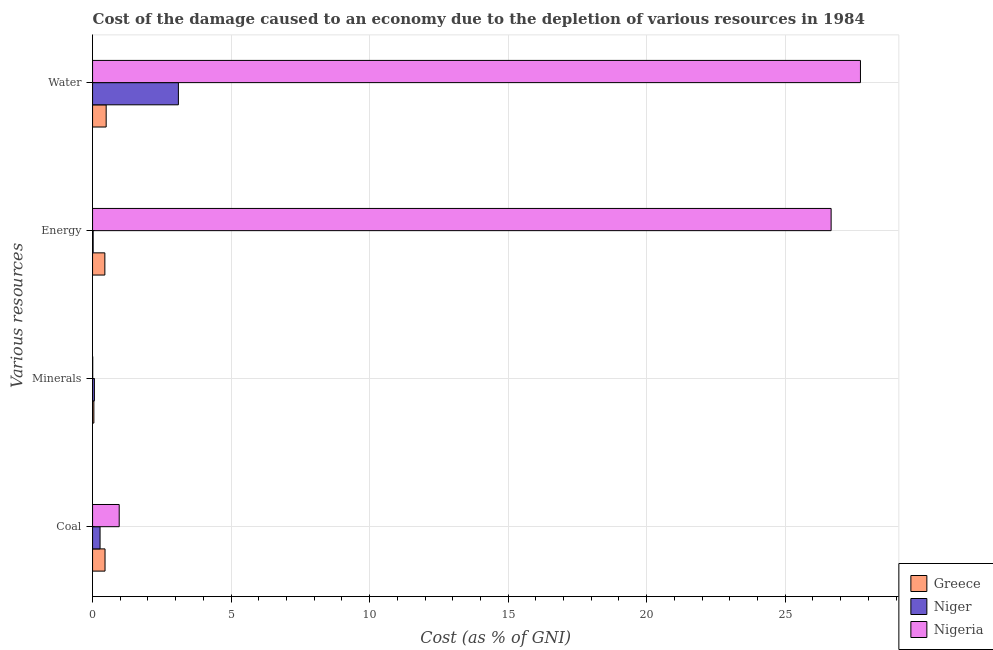How many different coloured bars are there?
Provide a succinct answer. 3. Are the number of bars per tick equal to the number of legend labels?
Your answer should be compact. Yes. Are the number of bars on each tick of the Y-axis equal?
Keep it short and to the point. Yes. How many bars are there on the 4th tick from the top?
Give a very brief answer. 3. How many bars are there on the 1st tick from the bottom?
Make the answer very short. 3. What is the label of the 3rd group of bars from the top?
Provide a short and direct response. Minerals. What is the cost of damage due to depletion of coal in Nigeria?
Keep it short and to the point. 0.96. Across all countries, what is the maximum cost of damage due to depletion of energy?
Ensure brevity in your answer.  26.66. Across all countries, what is the minimum cost of damage due to depletion of water?
Your answer should be very brief. 0.49. In which country was the cost of damage due to depletion of coal maximum?
Your answer should be compact. Nigeria. In which country was the cost of damage due to depletion of energy minimum?
Offer a terse response. Niger. What is the total cost of damage due to depletion of water in the graph?
Offer a very short reply. 31.31. What is the difference between the cost of damage due to depletion of coal in Nigeria and that in Greece?
Your answer should be very brief. 0.51. What is the difference between the cost of damage due to depletion of energy in Niger and the cost of damage due to depletion of coal in Nigeria?
Your answer should be very brief. -0.94. What is the average cost of damage due to depletion of water per country?
Your answer should be compact. 10.44. What is the difference between the cost of damage due to depletion of minerals and cost of damage due to depletion of coal in Greece?
Keep it short and to the point. -0.4. In how many countries, is the cost of damage due to depletion of energy greater than 19 %?
Your answer should be compact. 1. What is the ratio of the cost of damage due to depletion of minerals in Greece to that in Nigeria?
Your answer should be very brief. 8.82. Is the cost of damage due to depletion of minerals in Greece less than that in Niger?
Make the answer very short. Yes. Is the difference between the cost of damage due to depletion of water in Niger and Greece greater than the difference between the cost of damage due to depletion of coal in Niger and Greece?
Give a very brief answer. Yes. What is the difference between the highest and the second highest cost of damage due to depletion of coal?
Give a very brief answer. 0.51. What is the difference between the highest and the lowest cost of damage due to depletion of water?
Ensure brevity in your answer.  27.23. Is the sum of the cost of damage due to depletion of water in Greece and Niger greater than the maximum cost of damage due to depletion of minerals across all countries?
Your answer should be compact. Yes. Is it the case that in every country, the sum of the cost of damage due to depletion of energy and cost of damage due to depletion of minerals is greater than the sum of cost of damage due to depletion of coal and cost of damage due to depletion of water?
Provide a short and direct response. No. What does the 1st bar from the top in Coal represents?
Offer a very short reply. Nigeria. What does the 3rd bar from the bottom in Coal represents?
Your response must be concise. Nigeria. Are all the bars in the graph horizontal?
Provide a succinct answer. Yes. How many countries are there in the graph?
Provide a short and direct response. 3. What is the difference between two consecutive major ticks on the X-axis?
Your answer should be very brief. 5. Does the graph contain grids?
Give a very brief answer. Yes. How many legend labels are there?
Offer a terse response. 3. How are the legend labels stacked?
Make the answer very short. Vertical. What is the title of the graph?
Make the answer very short. Cost of the damage caused to an economy due to the depletion of various resources in 1984 . What is the label or title of the X-axis?
Offer a very short reply. Cost (as % of GNI). What is the label or title of the Y-axis?
Provide a short and direct response. Various resources. What is the Cost (as % of GNI) in Greece in Coal?
Ensure brevity in your answer.  0.45. What is the Cost (as % of GNI) in Niger in Coal?
Ensure brevity in your answer.  0.27. What is the Cost (as % of GNI) in Nigeria in Coal?
Your response must be concise. 0.96. What is the Cost (as % of GNI) in Greece in Minerals?
Ensure brevity in your answer.  0.05. What is the Cost (as % of GNI) of Niger in Minerals?
Your response must be concise. 0.07. What is the Cost (as % of GNI) of Nigeria in Minerals?
Give a very brief answer. 0.01. What is the Cost (as % of GNI) of Greece in Energy?
Give a very brief answer. 0.44. What is the Cost (as % of GNI) of Niger in Energy?
Keep it short and to the point. 0.02. What is the Cost (as % of GNI) of Nigeria in Energy?
Your answer should be very brief. 26.66. What is the Cost (as % of GNI) of Greece in Water?
Your answer should be very brief. 0.49. What is the Cost (as % of GNI) in Niger in Water?
Keep it short and to the point. 3.1. What is the Cost (as % of GNI) in Nigeria in Water?
Offer a very short reply. 27.72. Across all Various resources, what is the maximum Cost (as % of GNI) of Greece?
Make the answer very short. 0.49. Across all Various resources, what is the maximum Cost (as % of GNI) in Niger?
Keep it short and to the point. 3.1. Across all Various resources, what is the maximum Cost (as % of GNI) in Nigeria?
Keep it short and to the point. 27.72. Across all Various resources, what is the minimum Cost (as % of GNI) in Greece?
Offer a terse response. 0.05. Across all Various resources, what is the minimum Cost (as % of GNI) in Niger?
Provide a succinct answer. 0.02. Across all Various resources, what is the minimum Cost (as % of GNI) in Nigeria?
Offer a very short reply. 0.01. What is the total Cost (as % of GNI) of Greece in the graph?
Your answer should be compact. 1.43. What is the total Cost (as % of GNI) of Niger in the graph?
Give a very brief answer. 3.46. What is the total Cost (as % of GNI) of Nigeria in the graph?
Make the answer very short. 55.34. What is the difference between the Cost (as % of GNI) of Greece in Coal and that in Minerals?
Offer a very short reply. 0.4. What is the difference between the Cost (as % of GNI) of Niger in Coal and that in Minerals?
Give a very brief answer. 0.2. What is the difference between the Cost (as % of GNI) of Nigeria in Coal and that in Minerals?
Your answer should be very brief. 0.96. What is the difference between the Cost (as % of GNI) in Greece in Coal and that in Energy?
Ensure brevity in your answer.  0.01. What is the difference between the Cost (as % of GNI) in Niger in Coal and that in Energy?
Offer a terse response. 0.25. What is the difference between the Cost (as % of GNI) of Nigeria in Coal and that in Energy?
Ensure brevity in your answer.  -25.7. What is the difference between the Cost (as % of GNI) of Greece in Coal and that in Water?
Your answer should be compact. -0.04. What is the difference between the Cost (as % of GNI) of Niger in Coal and that in Water?
Make the answer very short. -2.83. What is the difference between the Cost (as % of GNI) of Nigeria in Coal and that in Water?
Provide a succinct answer. -26.76. What is the difference between the Cost (as % of GNI) in Greece in Minerals and that in Energy?
Give a very brief answer. -0.4. What is the difference between the Cost (as % of GNI) of Niger in Minerals and that in Energy?
Your answer should be very brief. 0.04. What is the difference between the Cost (as % of GNI) of Nigeria in Minerals and that in Energy?
Make the answer very short. -26.65. What is the difference between the Cost (as % of GNI) in Greece in Minerals and that in Water?
Make the answer very short. -0.44. What is the difference between the Cost (as % of GNI) of Niger in Minerals and that in Water?
Give a very brief answer. -3.03. What is the difference between the Cost (as % of GNI) of Nigeria in Minerals and that in Water?
Offer a very short reply. -27.71. What is the difference between the Cost (as % of GNI) of Greece in Energy and that in Water?
Keep it short and to the point. -0.05. What is the difference between the Cost (as % of GNI) in Niger in Energy and that in Water?
Your response must be concise. -3.08. What is the difference between the Cost (as % of GNI) in Nigeria in Energy and that in Water?
Keep it short and to the point. -1.06. What is the difference between the Cost (as % of GNI) in Greece in Coal and the Cost (as % of GNI) in Niger in Minerals?
Keep it short and to the point. 0.38. What is the difference between the Cost (as % of GNI) of Greece in Coal and the Cost (as % of GNI) of Nigeria in Minerals?
Give a very brief answer. 0.44. What is the difference between the Cost (as % of GNI) in Niger in Coal and the Cost (as % of GNI) in Nigeria in Minerals?
Provide a short and direct response. 0.27. What is the difference between the Cost (as % of GNI) of Greece in Coal and the Cost (as % of GNI) of Niger in Energy?
Offer a terse response. 0.43. What is the difference between the Cost (as % of GNI) in Greece in Coal and the Cost (as % of GNI) in Nigeria in Energy?
Ensure brevity in your answer.  -26.21. What is the difference between the Cost (as % of GNI) of Niger in Coal and the Cost (as % of GNI) of Nigeria in Energy?
Your response must be concise. -26.39. What is the difference between the Cost (as % of GNI) in Greece in Coal and the Cost (as % of GNI) in Niger in Water?
Your response must be concise. -2.65. What is the difference between the Cost (as % of GNI) in Greece in Coal and the Cost (as % of GNI) in Nigeria in Water?
Provide a short and direct response. -27.27. What is the difference between the Cost (as % of GNI) of Niger in Coal and the Cost (as % of GNI) of Nigeria in Water?
Provide a succinct answer. -27.45. What is the difference between the Cost (as % of GNI) in Greece in Minerals and the Cost (as % of GNI) in Niger in Energy?
Give a very brief answer. 0.03. What is the difference between the Cost (as % of GNI) of Greece in Minerals and the Cost (as % of GNI) of Nigeria in Energy?
Your answer should be compact. -26.61. What is the difference between the Cost (as % of GNI) in Niger in Minerals and the Cost (as % of GNI) in Nigeria in Energy?
Provide a short and direct response. -26.59. What is the difference between the Cost (as % of GNI) in Greece in Minerals and the Cost (as % of GNI) in Niger in Water?
Your answer should be very brief. -3.05. What is the difference between the Cost (as % of GNI) of Greece in Minerals and the Cost (as % of GNI) of Nigeria in Water?
Your answer should be very brief. -27.67. What is the difference between the Cost (as % of GNI) in Niger in Minerals and the Cost (as % of GNI) in Nigeria in Water?
Provide a succinct answer. -27.65. What is the difference between the Cost (as % of GNI) of Greece in Energy and the Cost (as % of GNI) of Niger in Water?
Your answer should be compact. -2.65. What is the difference between the Cost (as % of GNI) in Greece in Energy and the Cost (as % of GNI) in Nigeria in Water?
Give a very brief answer. -27.27. What is the difference between the Cost (as % of GNI) in Niger in Energy and the Cost (as % of GNI) in Nigeria in Water?
Your answer should be compact. -27.7. What is the average Cost (as % of GNI) of Greece per Various resources?
Your answer should be compact. 0.36. What is the average Cost (as % of GNI) in Niger per Various resources?
Offer a terse response. 0.86. What is the average Cost (as % of GNI) in Nigeria per Various resources?
Offer a terse response. 13.84. What is the difference between the Cost (as % of GNI) in Greece and Cost (as % of GNI) in Niger in Coal?
Ensure brevity in your answer.  0.18. What is the difference between the Cost (as % of GNI) of Greece and Cost (as % of GNI) of Nigeria in Coal?
Your answer should be very brief. -0.51. What is the difference between the Cost (as % of GNI) in Niger and Cost (as % of GNI) in Nigeria in Coal?
Ensure brevity in your answer.  -0.69. What is the difference between the Cost (as % of GNI) in Greece and Cost (as % of GNI) in Niger in Minerals?
Ensure brevity in your answer.  -0.02. What is the difference between the Cost (as % of GNI) of Greece and Cost (as % of GNI) of Nigeria in Minerals?
Offer a terse response. 0.04. What is the difference between the Cost (as % of GNI) of Niger and Cost (as % of GNI) of Nigeria in Minerals?
Your answer should be compact. 0.06. What is the difference between the Cost (as % of GNI) in Greece and Cost (as % of GNI) in Niger in Energy?
Give a very brief answer. 0.42. What is the difference between the Cost (as % of GNI) of Greece and Cost (as % of GNI) of Nigeria in Energy?
Your answer should be very brief. -26.21. What is the difference between the Cost (as % of GNI) in Niger and Cost (as % of GNI) in Nigeria in Energy?
Your response must be concise. -26.64. What is the difference between the Cost (as % of GNI) of Greece and Cost (as % of GNI) of Niger in Water?
Ensure brevity in your answer.  -2.61. What is the difference between the Cost (as % of GNI) of Greece and Cost (as % of GNI) of Nigeria in Water?
Keep it short and to the point. -27.23. What is the difference between the Cost (as % of GNI) in Niger and Cost (as % of GNI) in Nigeria in Water?
Your response must be concise. -24.62. What is the ratio of the Cost (as % of GNI) of Greece in Coal to that in Minerals?
Provide a succinct answer. 9.53. What is the ratio of the Cost (as % of GNI) in Niger in Coal to that in Minerals?
Your response must be concise. 4.1. What is the ratio of the Cost (as % of GNI) of Nigeria in Coal to that in Minerals?
Provide a short and direct response. 179.5. What is the ratio of the Cost (as % of GNI) in Niger in Coal to that in Energy?
Ensure brevity in your answer.  12.71. What is the ratio of the Cost (as % of GNI) in Nigeria in Coal to that in Energy?
Offer a terse response. 0.04. What is the ratio of the Cost (as % of GNI) in Greece in Coal to that in Water?
Make the answer very short. 0.92. What is the ratio of the Cost (as % of GNI) in Niger in Coal to that in Water?
Your answer should be compact. 0.09. What is the ratio of the Cost (as % of GNI) of Nigeria in Coal to that in Water?
Your answer should be compact. 0.03. What is the ratio of the Cost (as % of GNI) of Greece in Minerals to that in Energy?
Give a very brief answer. 0.11. What is the ratio of the Cost (as % of GNI) in Niger in Minerals to that in Energy?
Your answer should be compact. 3.1. What is the ratio of the Cost (as % of GNI) of Nigeria in Minerals to that in Energy?
Keep it short and to the point. 0. What is the ratio of the Cost (as % of GNI) of Greece in Minerals to that in Water?
Provide a succinct answer. 0.1. What is the ratio of the Cost (as % of GNI) of Niger in Minerals to that in Water?
Your answer should be very brief. 0.02. What is the ratio of the Cost (as % of GNI) of Nigeria in Minerals to that in Water?
Give a very brief answer. 0. What is the ratio of the Cost (as % of GNI) in Greece in Energy to that in Water?
Your answer should be compact. 0.9. What is the ratio of the Cost (as % of GNI) in Niger in Energy to that in Water?
Make the answer very short. 0.01. What is the ratio of the Cost (as % of GNI) of Nigeria in Energy to that in Water?
Give a very brief answer. 0.96. What is the difference between the highest and the second highest Cost (as % of GNI) in Greece?
Your response must be concise. 0.04. What is the difference between the highest and the second highest Cost (as % of GNI) in Niger?
Ensure brevity in your answer.  2.83. What is the difference between the highest and the second highest Cost (as % of GNI) in Nigeria?
Give a very brief answer. 1.06. What is the difference between the highest and the lowest Cost (as % of GNI) of Greece?
Make the answer very short. 0.44. What is the difference between the highest and the lowest Cost (as % of GNI) of Niger?
Your response must be concise. 3.08. What is the difference between the highest and the lowest Cost (as % of GNI) of Nigeria?
Offer a very short reply. 27.71. 